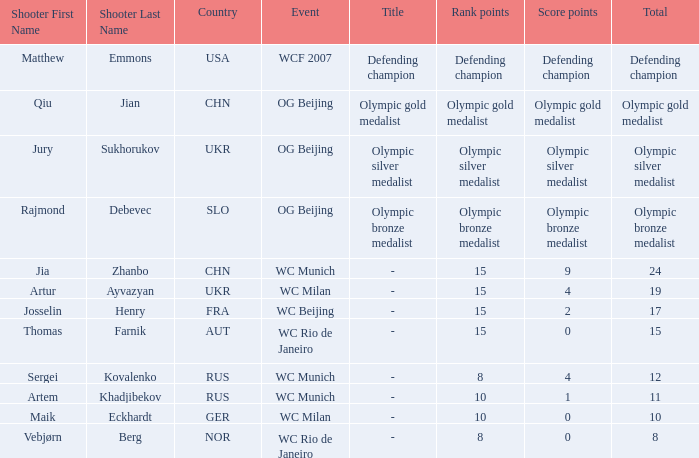With a total of 11, what is the score points? 1.0. 